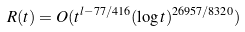<formula> <loc_0><loc_0><loc_500><loc_500>R ( t ) = O ( t ^ { l - 7 7 / 4 1 6 } ( \log t ) ^ { 2 6 9 5 7 / 8 3 2 0 } )</formula> 